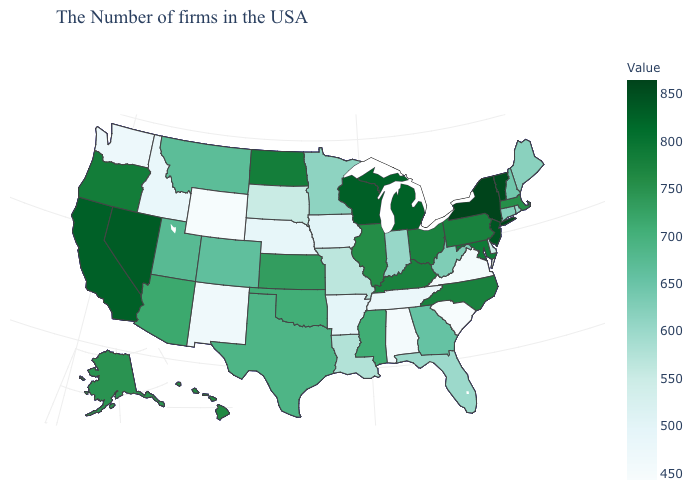Among the states that border Idaho , does Washington have the lowest value?
Give a very brief answer. No. Does Maryland have the highest value in the South?
Give a very brief answer. Yes. Among the states that border New Jersey , which have the highest value?
Give a very brief answer. New York. Does Kansas have a higher value than New York?
Write a very short answer. No. 